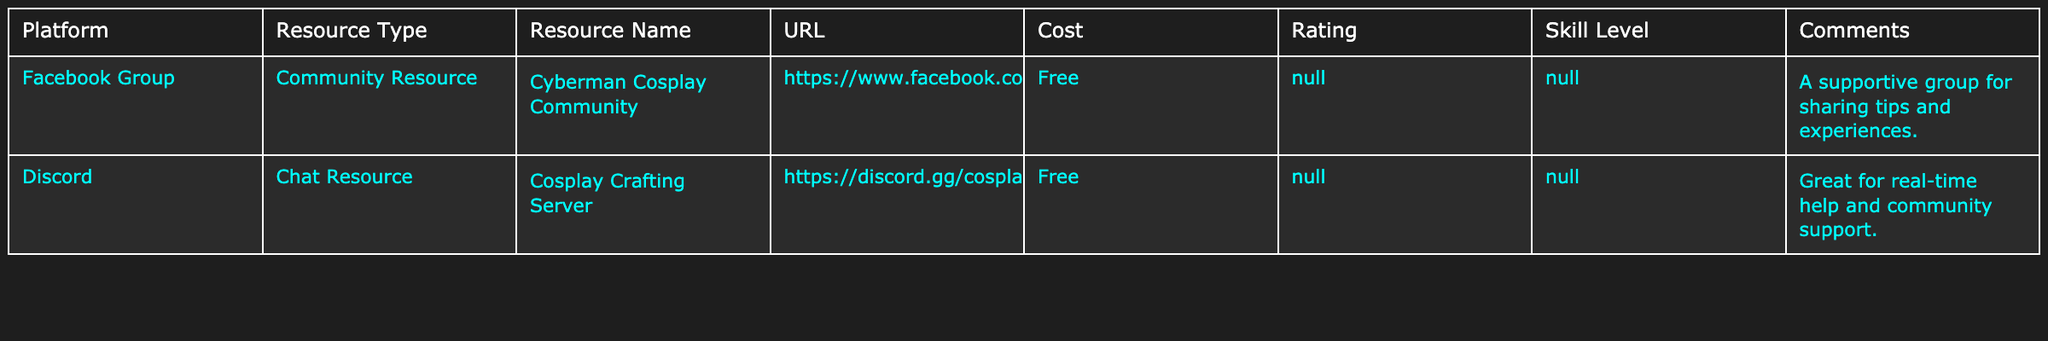What platform offers a free community resource for Cyberman costumes? The table lists "Facebook Group" as a platform that offers a free community resource titled "Cyberman Cosplay Community."
Answer: Facebook Group How many resource types are listed in the table? There are two resource types mentioned: Community Resource and Chat Resource.
Answer: 2 Is there a resource in the table that has a cost associated with it? Both resources listed in the table are marked as free, indicating that there are no costs associated with them.
Answer: No Which platform includes a resource for real-time help for costume crafting? The table indicates that the "Cosplay Crafting Server" on Discord provides real-time help.
Answer: Discord What is the URL for the Cyberman Cosplay Community? The table lists the URL for the Cyberman Cosplay Community under the Facebook Group as https://www.facebook.com/groups/cyberman.cosplay.
Answer: https://www.facebook.com/groups/cyberman.cosplay Which platform has a resource that does not provide a skill level rating? The table shows that both the resources listed (on Facebook and Discord) do not provide a skill level rating, as indicated by "N/A."
Answer: Both platforms How many total resources are listed in the table? The table lists two resources: one from Facebook and one from Discord, totaling two resources.
Answer: 2 Are all resources rated the same in terms of cost? The table shows that all resources are listed as free, indicating they all have the same cost rating.
Answer: Yes What type of support is mentioned in the comments for the Cyberman Cosplay Community? The comment for the Cyberman Cosplay Community mentions that it is a supportive group for sharing tips and experiences.
Answer: Supportive group Which community resource provides comments on user interaction? The "Cosplay Crafting Server" on Discord provides comments about great real-time help and community support.
Answer: Discord 